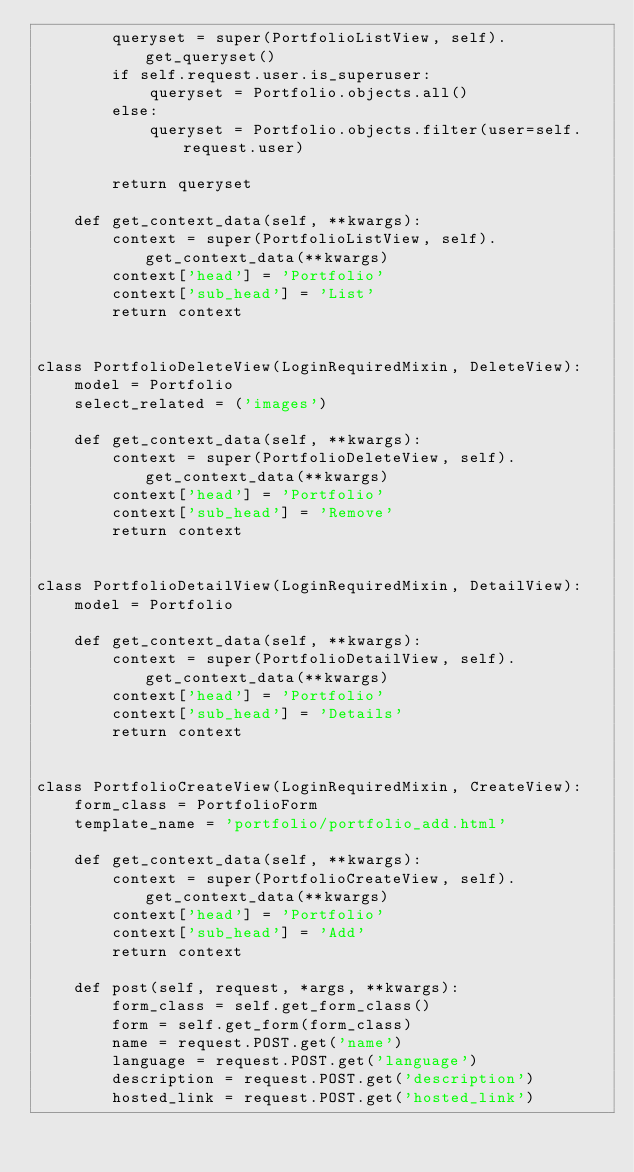<code> <loc_0><loc_0><loc_500><loc_500><_Python_>        queryset = super(PortfolioListView, self).get_queryset()
        if self.request.user.is_superuser:
            queryset = Portfolio.objects.all()
        else:
            queryset = Portfolio.objects.filter(user=self.request.user)

        return queryset

    def get_context_data(self, **kwargs):
        context = super(PortfolioListView, self).get_context_data(**kwargs)
        context['head'] = 'Portfolio'
        context['sub_head'] = 'List'
        return context


class PortfolioDeleteView(LoginRequiredMixin, DeleteView):
    model = Portfolio
    select_related = ('images')

    def get_context_data(self, **kwargs):
        context = super(PortfolioDeleteView, self).get_context_data(**kwargs)
        context['head'] = 'Portfolio'
        context['sub_head'] = 'Remove'
        return context


class PortfolioDetailView(LoginRequiredMixin, DetailView):
    model = Portfolio

    def get_context_data(self, **kwargs):
        context = super(PortfolioDetailView, self).get_context_data(**kwargs)
        context['head'] = 'Portfolio'
        context['sub_head'] = 'Details'
        return context


class PortfolioCreateView(LoginRequiredMixin, CreateView):
    form_class = PortfolioForm
    template_name = 'portfolio/portfolio_add.html'

    def get_context_data(self, **kwargs):
        context = super(PortfolioCreateView, self).get_context_data(**kwargs)
        context['head'] = 'Portfolio'
        context['sub_head'] = 'Add'
        return context

    def post(self, request, *args, **kwargs):
        form_class = self.get_form_class()
        form = self.get_form(form_class)
        name = request.POST.get('name')
        language = request.POST.get('language')
        description = request.POST.get('description')
        hosted_link = request.POST.get('hosted_link')</code> 